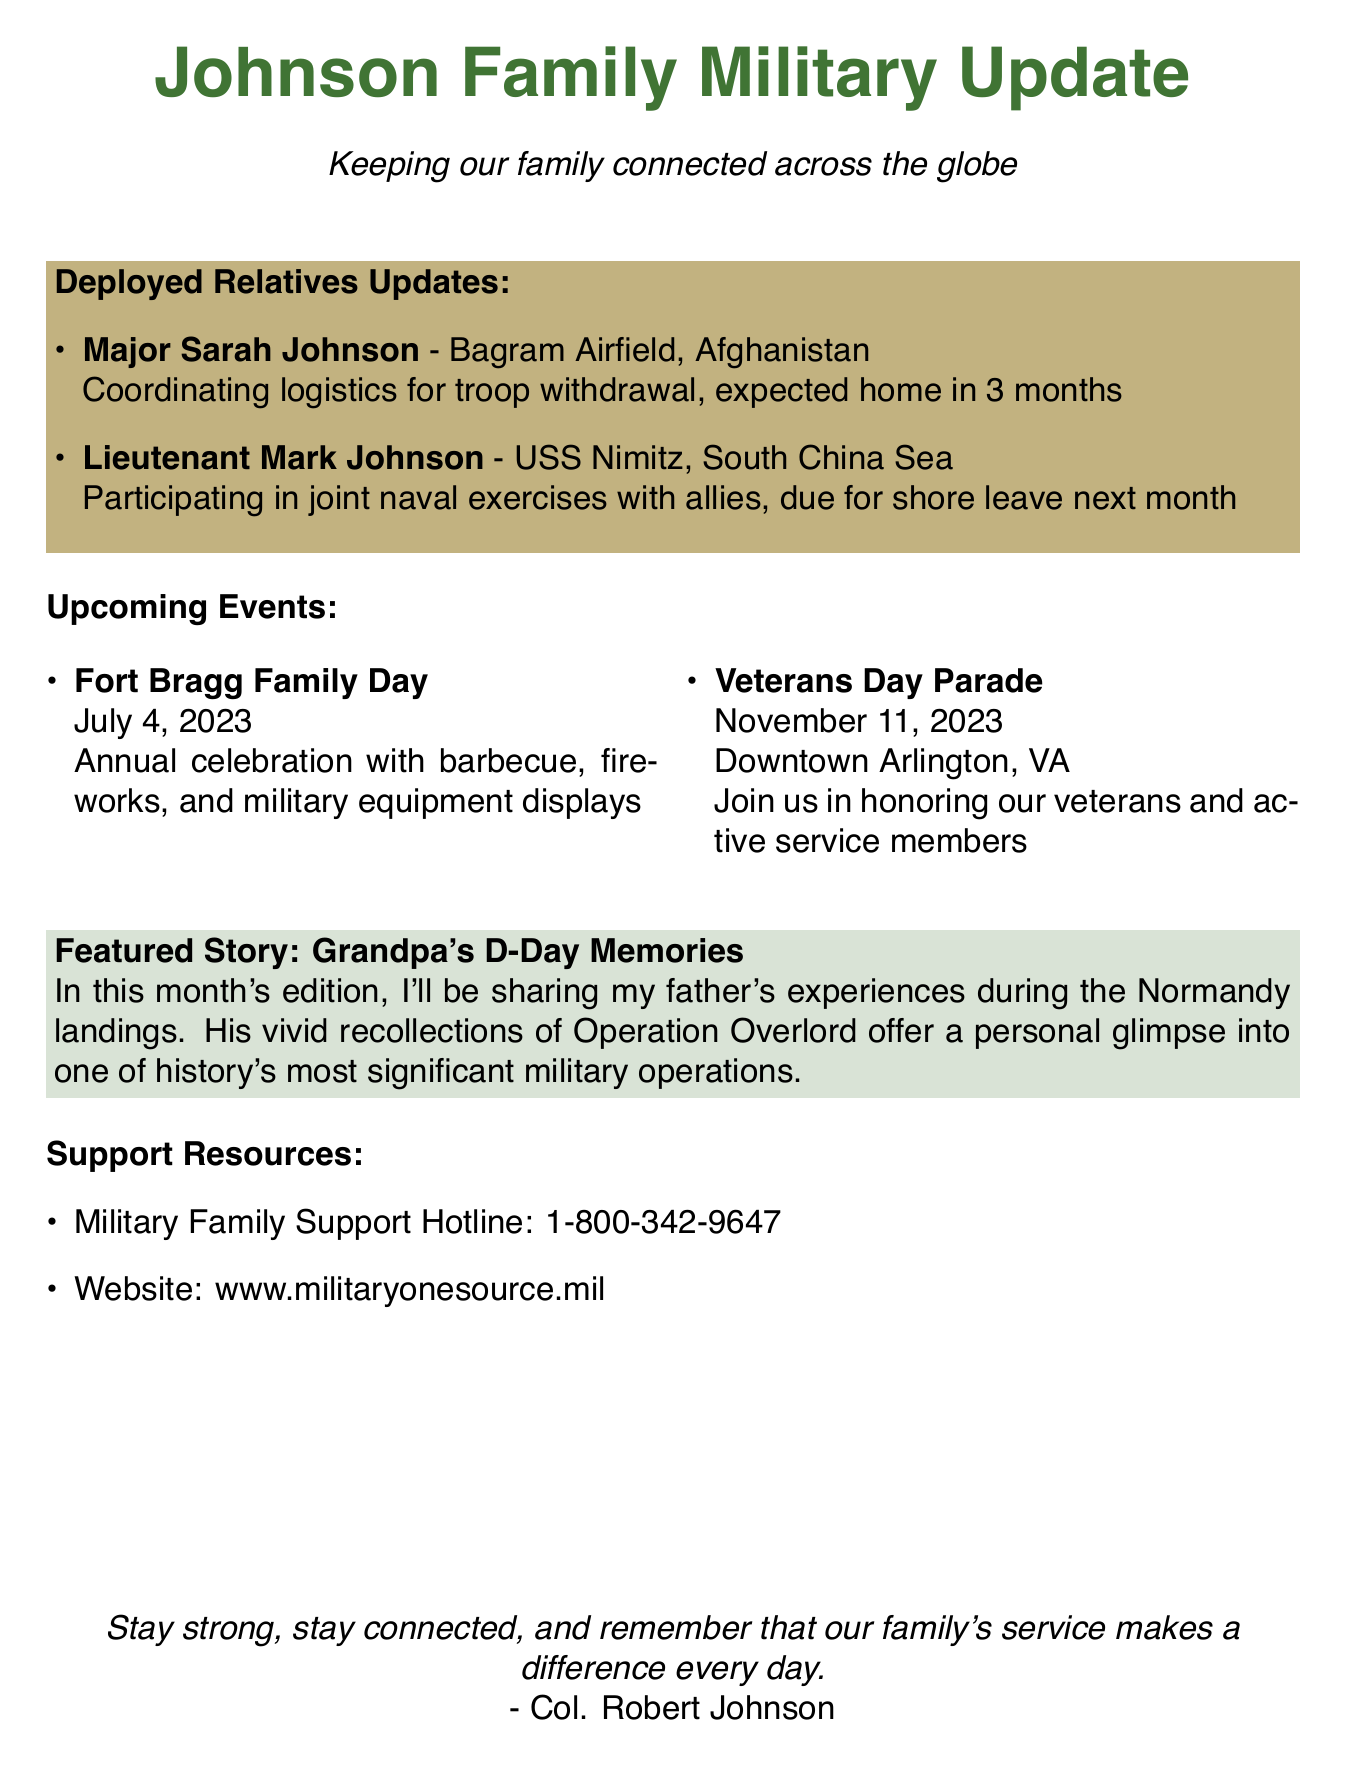What is the title of the newsletter? The title is indicated at the beginning of the document and is "Johnson Family Military Update".
Answer: Johnson Family Military Update Who is coordinating logistics for troop withdrawal? The deployed relative mentioned for this task is Major Sarah Johnson.
Answer: Major Sarah Johnson What is the expected return time for Major Sarah Johnson? The document states that she is expected home in 3 months.
Answer: 3 months When is the Fort Bragg Family Day event scheduled? The date of the event is clearly stated in the upcoming events section as July 4, 2023.
Answer: July 4, 2023 Where will the Veterans Day Parade take place? The document specifies that it will be held in Downtown Arlington, VA.
Answer: Downtown Arlington, VA What is the focus of the featured story in this newsletter? The featured story discusses Grandpa's experiences during the Normandy landings.
Answer: Grandpa's D-Day Memories How can family members get support? The document includes a support resource section with a hotline and a website for military family support.
Answer: 1-800-342-9647 What type of event is the Fort Bragg Family Day? The description indicates it is an annual celebration with various activities like barbecue and fireworks.
Answer: Annual celebration Who authored the closing message? The closing message is signed by Col. Robert Johnson.
Answer: Col. Robert Johnson 